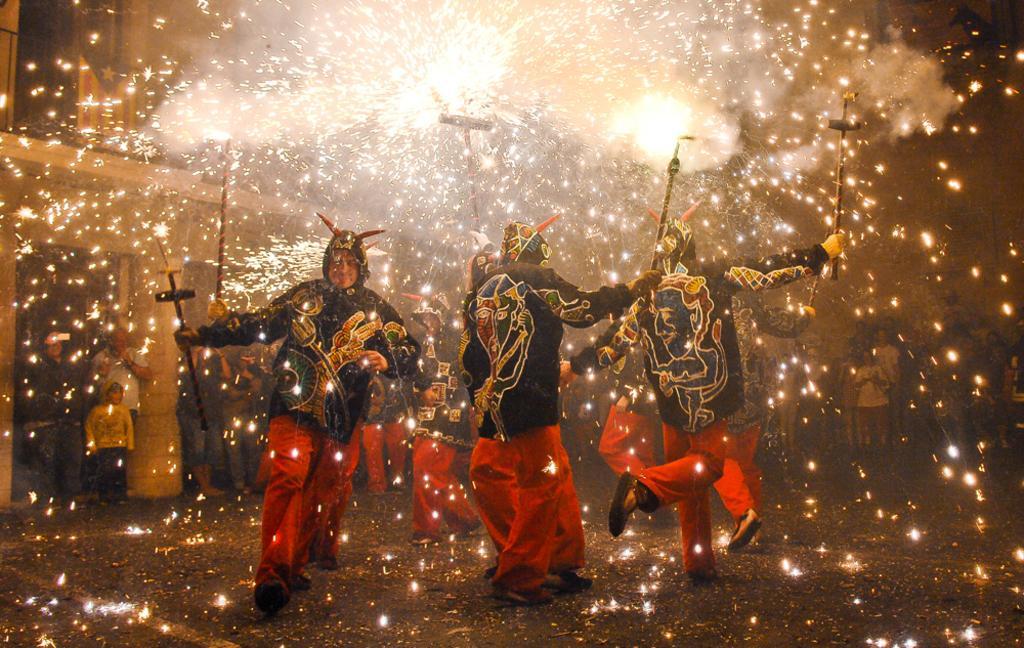Describe this image in one or two sentences. In this picture there is a group of persons who are wearing the same dress and holding the cross mark sticks in their hands. On the left there is a man who is wearing t-shirt and trouser. Beside him there is a boy who is wearing yellow hoodie, trouser and shoe. Beside him I can see another man who is wearing hoodie, jeans and shoe. Three of them were standing near to the door. In the back I can see some people were standing near to the tree and buildings. 